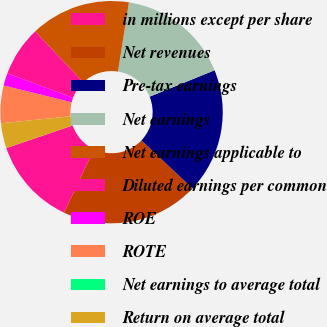Convert chart. <chart><loc_0><loc_0><loc_500><loc_500><pie_chart><fcel>in millions except per share<fcel>Net revenues<fcel>Pre-tax earnings<fcel>Net earnings<fcel>Net earnings applicable to<fcel>Diluted earnings per common<fcel>ROE<fcel>ROTE<fcel>Net earnings to average total<fcel>Return on average total<nl><fcel>12.73%<fcel>20.0%<fcel>18.18%<fcel>16.36%<fcel>14.55%<fcel>7.27%<fcel>1.82%<fcel>5.45%<fcel>0.0%<fcel>3.64%<nl></chart> 